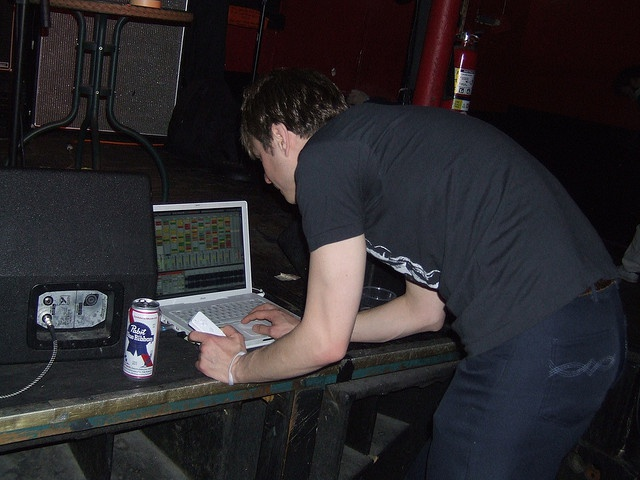Describe the objects in this image and their specific colors. I can see people in black, darkgray, and tan tones, laptop in black, gray, darkgray, and purple tones, dining table in black, maroon, and gray tones, cup in black and gray tones, and remote in black, lightgray, darkgray, and gray tones in this image. 